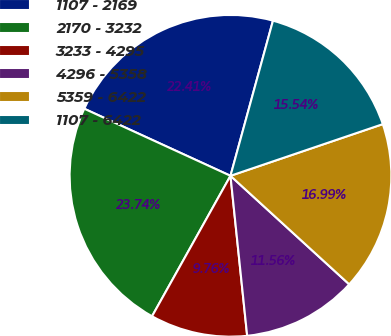Convert chart. <chart><loc_0><loc_0><loc_500><loc_500><pie_chart><fcel>1107 - 2169<fcel>2170 - 3232<fcel>3233 - 4295<fcel>4296 - 5358<fcel>5359 - 6422<fcel>1107 - 6422<nl><fcel>22.41%<fcel>23.74%<fcel>9.76%<fcel>11.56%<fcel>16.99%<fcel>15.54%<nl></chart> 